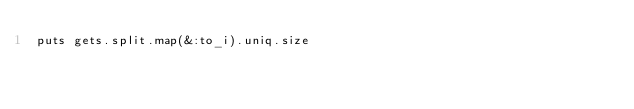<code> <loc_0><loc_0><loc_500><loc_500><_Ruby_>puts gets.split.map(&:to_i).uniq.size</code> 